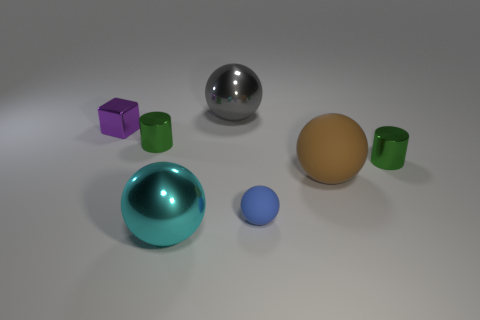Is there any other thing that is the same shape as the tiny matte thing?
Ensure brevity in your answer.  Yes. Does the big gray thing have the same material as the tiny blue thing that is in front of the tiny metal block?
Ensure brevity in your answer.  No. What color is the big object on the right side of the metal sphere behind the small thing in front of the large matte object?
Your response must be concise. Brown. Is there anything else that is the same size as the cyan sphere?
Offer a very short reply. Yes. There is a small rubber thing; is its color the same as the big metal object that is behind the purple block?
Provide a succinct answer. No. The small ball has what color?
Ensure brevity in your answer.  Blue. There is a small green object that is on the left side of the green object that is on the right side of the sphere behind the shiny cube; what is its shape?
Give a very brief answer. Cylinder. How many other objects are there of the same color as the tiny rubber thing?
Offer a terse response. 0. Is the number of small purple blocks that are on the left side of the brown rubber sphere greater than the number of shiny spheres that are on the left side of the shiny block?
Your answer should be very brief. Yes. There is a large cyan metal sphere; are there any large things behind it?
Keep it short and to the point. Yes. 